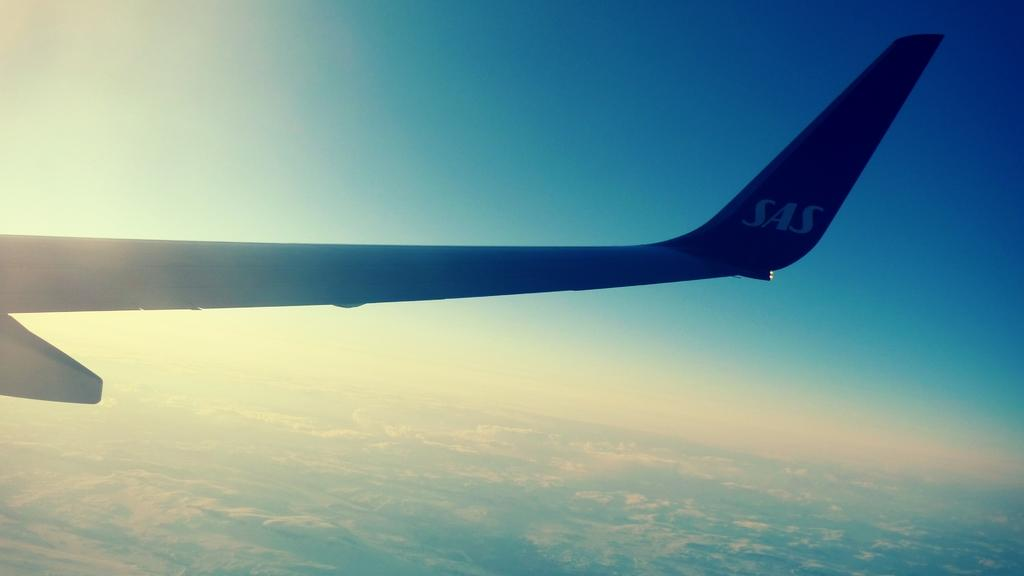What is the main subject of the image? The main subject of the image is an airplane. What is the airplane doing in the image? The airplane is flying in the sky. What can be seen below the airplane in the image? The ground is visible below the airplane. Can you see the elbow of the goldfish in the image? There is no goldfish or elbow present in the image; it features an airplane flying in the sky. 